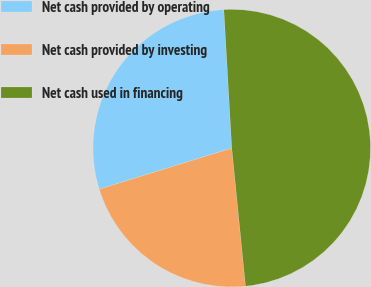Convert chart. <chart><loc_0><loc_0><loc_500><loc_500><pie_chart><fcel>Net cash provided by operating<fcel>Net cash provided by investing<fcel>Net cash used in financing<nl><fcel>28.87%<fcel>21.8%<fcel>49.32%<nl></chart> 